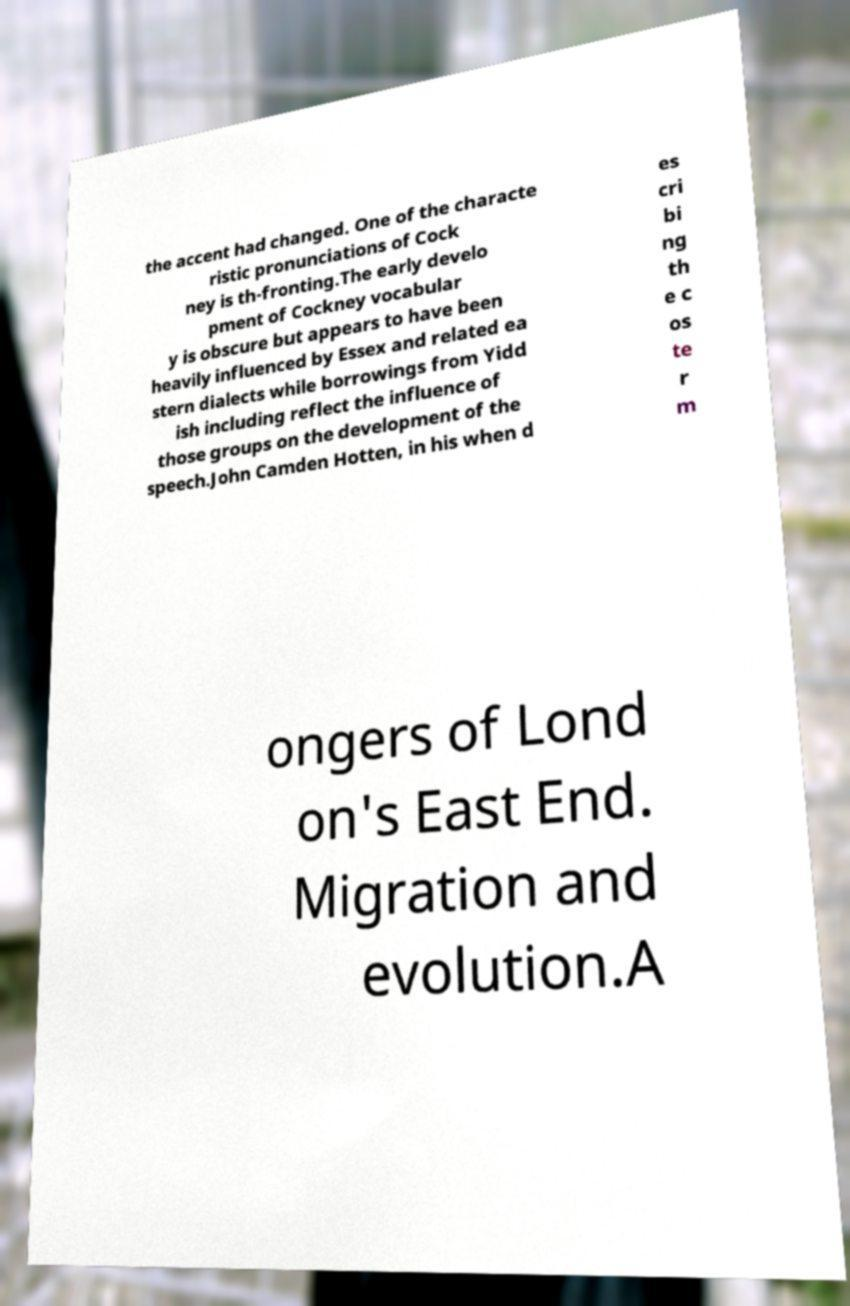I need the written content from this picture converted into text. Can you do that? the accent had changed. One of the characte ristic pronunciations of Cock ney is th-fronting.The early develo pment of Cockney vocabular y is obscure but appears to have been heavily influenced by Essex and related ea stern dialects while borrowings from Yidd ish including reflect the influence of those groups on the development of the speech.John Camden Hotten, in his when d es cri bi ng th e c os te r m ongers of Lond on's East End. Migration and evolution.A 